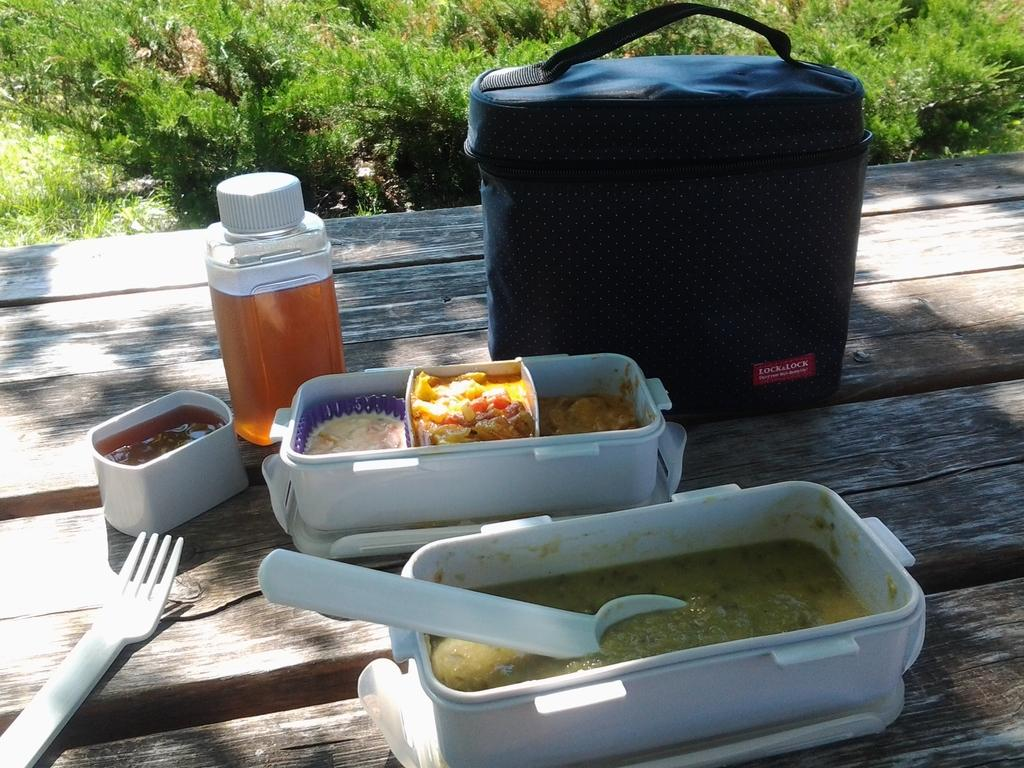<image>
Summarize the visual content of the image. A lunch box on a picnic table that says Lock & Lock on it 